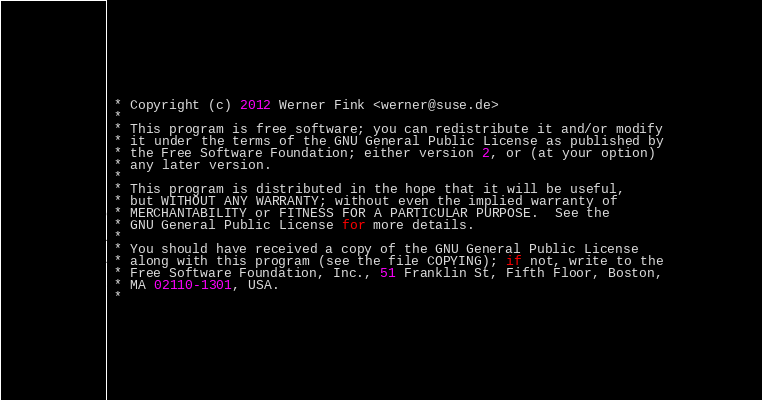<code> <loc_0><loc_0><loc_500><loc_500><_C_> * Copyright (c) 2012 Werner Fink <werner@suse.de>
 *
 * This program is free software; you can redistribute it and/or modify
 * it under the terms of the GNU General Public License as published by
 * the Free Software Foundation; either version 2, or (at your option)
 * any later version.
 *  
 * This program is distributed in the hope that it will be useful,
 * but WITHOUT ANY WARRANTY; without even the implied warranty of
 * MERCHANTABILITY or FITNESS FOR A PARTICULAR PURPOSE.  See the
 * GNU General Public License for more details.
 *
 * You should have received a copy of the GNU General Public License
 * along with this program (see the file COPYING); if not, write to the
 * Free Software Foundation, Inc., 51 Franklin St, Fifth Floor, Boston,
 * MA 02110-1301, USA.
 *</code> 